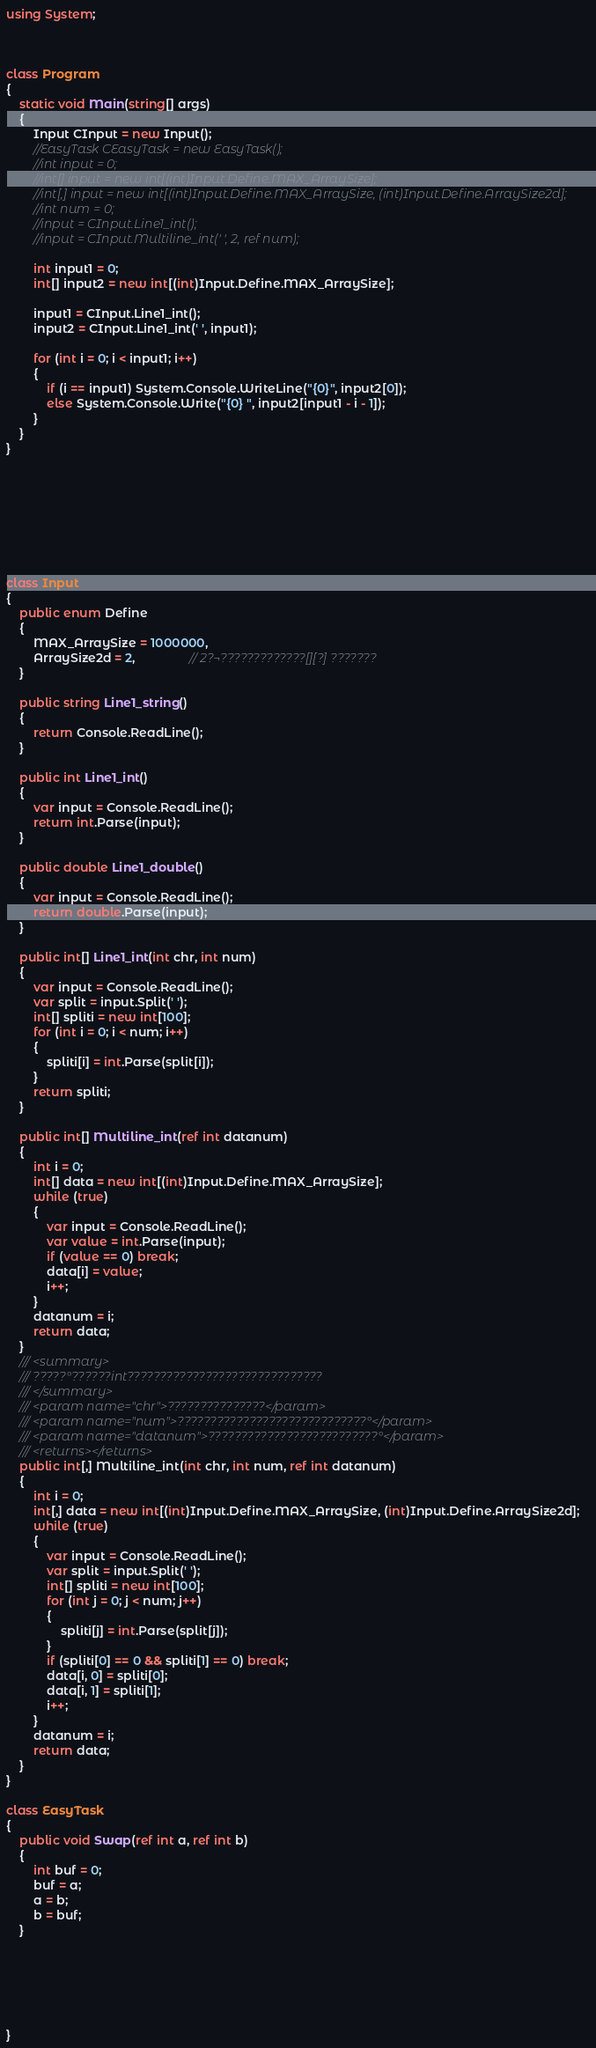<code> <loc_0><loc_0><loc_500><loc_500><_C#_>using System;



class Program
{
    static void Main(string[] args)
    {
        Input CInput = new Input();
        //EasyTask CEasyTask = new EasyTask();
        //int input = 0;
        //int[] input = new int[(int)Input.Define.MAX_ArraySize];
        //int[,] input = new int[(int)Input.Define.MAX_ArraySize, (int)Input.Define.ArraySize2d];
        //int num = 0;
        //input = CInput.Line1_int();
        //input = CInput.Multiline_int(' ', 2, ref num);

        int input1 = 0;
        int[] input2 = new int[(int)Input.Define.MAX_ArraySize];

        input1 = CInput.Line1_int();
        input2 = CInput.Line1_int(' ', input1);

        for (int i = 0; i < input1; i++)
        {
            if (i == input1) System.Console.WriteLine("{0}", input2[0]);
            else System.Console.Write("{0} ", input2[input1 - i - 1]);
        }
    }
}








class Input
{
    public enum Define
    {
        MAX_ArraySize = 1000000,
        ArraySize2d = 2,                // 2?¬?????????????[][?] ???????
    }

    public string Line1_string()
    {
        return Console.ReadLine();
    }

    public int Line1_int()
    {
        var input = Console.ReadLine();
        return int.Parse(input);
    }

    public double Line1_double()
    {
        var input = Console.ReadLine();
        return double.Parse(input);
    }

    public int[] Line1_int(int chr, int num)
    {
        var input = Console.ReadLine();
        var split = input.Split(' ');
        int[] spliti = new int[100];
        for (int i = 0; i < num; i++)
        {
            spliti[i] = int.Parse(split[i]);
        }
        return spliti;
    }

    public int[] Multiline_int(ref int datanum)
    {
        int i = 0;
        int[] data = new int[(int)Input.Define.MAX_ArraySize];
        while (true)
        {
            var input = Console.ReadLine();
            var value = int.Parse(input);
            if (value == 0) break;
            data[i] = value;
            i++;
        }
        datanum = i;
        return data;
    }
    /// <summary>
    /// ?????°??????int??????????????????????????????
    /// </summary>
    /// <param name="chr">???????????????</param>
    /// <param name="num">?????????????????????????????°</param>
    /// <param name="datanum">??????????????????????????°</param>
    /// <returns></returns>
    public int[,] Multiline_int(int chr, int num, ref int datanum)
    {
        int i = 0;
        int[,] data = new int[(int)Input.Define.MAX_ArraySize, (int)Input.Define.ArraySize2d];
        while (true)
        {
            var input = Console.ReadLine();
            var split = input.Split(' ');
            int[] spliti = new int[100];
            for (int j = 0; j < num; j++)
            {
                spliti[j] = int.Parse(split[j]);
            }
            if (spliti[0] == 0 && spliti[1] == 0) break;
            data[i, 0] = spliti[0];
            data[i, 1] = spliti[1];
            i++;
        }
        datanum = i;
        return data;
    }
}

class EasyTask
{
    public void Swap(ref int a, ref int b)
    {
        int buf = 0;
        buf = a;
        a = b;
        b = buf;
    }






}</code> 